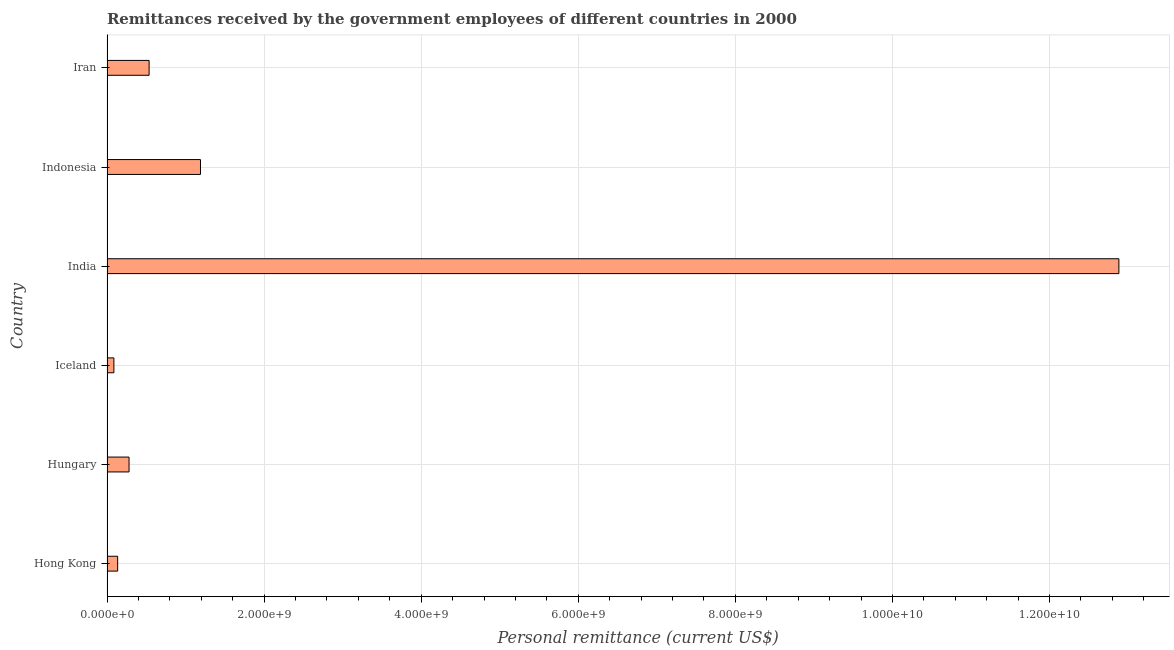Does the graph contain any zero values?
Offer a very short reply. No. What is the title of the graph?
Offer a very short reply. Remittances received by the government employees of different countries in 2000. What is the label or title of the X-axis?
Keep it short and to the point. Personal remittance (current US$). What is the label or title of the Y-axis?
Your response must be concise. Country. What is the personal remittances in Hungary?
Give a very brief answer. 2.81e+08. Across all countries, what is the maximum personal remittances?
Provide a succinct answer. 1.29e+1. Across all countries, what is the minimum personal remittances?
Your answer should be compact. 8.76e+07. In which country was the personal remittances maximum?
Give a very brief answer. India. What is the sum of the personal remittances?
Provide a succinct answer. 1.51e+1. What is the difference between the personal remittances in Hong Kong and Iran?
Your response must be concise. -4.00e+08. What is the average personal remittances per country?
Provide a succinct answer. 2.52e+09. What is the median personal remittances?
Offer a terse response. 4.08e+08. In how many countries, is the personal remittances greater than 8800000000 US$?
Your answer should be very brief. 1. What is the ratio of the personal remittances in Hong Kong to that in Iran?
Make the answer very short. 0.25. Is the personal remittances in Hungary less than that in Iran?
Give a very brief answer. Yes. What is the difference between the highest and the second highest personal remittances?
Your response must be concise. 1.17e+1. What is the difference between the highest and the lowest personal remittances?
Give a very brief answer. 1.28e+1. In how many countries, is the personal remittances greater than the average personal remittances taken over all countries?
Your response must be concise. 1. How many bars are there?
Your answer should be very brief. 6. Are all the bars in the graph horizontal?
Provide a short and direct response. Yes. How many countries are there in the graph?
Your answer should be very brief. 6. What is the difference between two consecutive major ticks on the X-axis?
Provide a short and direct response. 2.00e+09. What is the Personal remittance (current US$) of Hong Kong?
Your answer should be compact. 1.36e+08. What is the Personal remittance (current US$) in Hungary?
Offer a terse response. 2.81e+08. What is the Personal remittance (current US$) in Iceland?
Your answer should be compact. 8.76e+07. What is the Personal remittance (current US$) of India?
Your response must be concise. 1.29e+1. What is the Personal remittance (current US$) of Indonesia?
Ensure brevity in your answer.  1.19e+09. What is the Personal remittance (current US$) of Iran?
Provide a short and direct response. 5.36e+08. What is the difference between the Personal remittance (current US$) in Hong Kong and Hungary?
Your answer should be very brief. -1.45e+08. What is the difference between the Personal remittance (current US$) in Hong Kong and Iceland?
Provide a short and direct response. 4.79e+07. What is the difference between the Personal remittance (current US$) in Hong Kong and India?
Make the answer very short. -1.27e+1. What is the difference between the Personal remittance (current US$) in Hong Kong and Indonesia?
Offer a terse response. -1.05e+09. What is the difference between the Personal remittance (current US$) in Hong Kong and Iran?
Ensure brevity in your answer.  -4.00e+08. What is the difference between the Personal remittance (current US$) in Hungary and Iceland?
Offer a very short reply. 1.93e+08. What is the difference between the Personal remittance (current US$) in Hungary and India?
Offer a very short reply. -1.26e+1. What is the difference between the Personal remittance (current US$) in Hungary and Indonesia?
Ensure brevity in your answer.  -9.10e+08. What is the difference between the Personal remittance (current US$) in Hungary and Iran?
Your response must be concise. -2.55e+08. What is the difference between the Personal remittance (current US$) in Iceland and India?
Give a very brief answer. -1.28e+1. What is the difference between the Personal remittance (current US$) in Iceland and Indonesia?
Your answer should be compact. -1.10e+09. What is the difference between the Personal remittance (current US$) in Iceland and Iran?
Your response must be concise. -4.48e+08. What is the difference between the Personal remittance (current US$) in India and Indonesia?
Make the answer very short. 1.17e+1. What is the difference between the Personal remittance (current US$) in India and Iran?
Your answer should be very brief. 1.23e+1. What is the difference between the Personal remittance (current US$) in Indonesia and Iran?
Your response must be concise. 6.54e+08. What is the ratio of the Personal remittance (current US$) in Hong Kong to that in Hungary?
Give a very brief answer. 0.48. What is the ratio of the Personal remittance (current US$) in Hong Kong to that in Iceland?
Keep it short and to the point. 1.55. What is the ratio of the Personal remittance (current US$) in Hong Kong to that in India?
Provide a succinct answer. 0.01. What is the ratio of the Personal remittance (current US$) in Hong Kong to that in Indonesia?
Keep it short and to the point. 0.11. What is the ratio of the Personal remittance (current US$) in Hong Kong to that in Iran?
Provide a short and direct response. 0.25. What is the ratio of the Personal remittance (current US$) in Hungary to that in Iceland?
Make the answer very short. 3.2. What is the ratio of the Personal remittance (current US$) in Hungary to that in India?
Provide a short and direct response. 0.02. What is the ratio of the Personal remittance (current US$) in Hungary to that in Indonesia?
Provide a short and direct response. 0.24. What is the ratio of the Personal remittance (current US$) in Hungary to that in Iran?
Offer a terse response. 0.52. What is the ratio of the Personal remittance (current US$) in Iceland to that in India?
Your response must be concise. 0.01. What is the ratio of the Personal remittance (current US$) in Iceland to that in Indonesia?
Offer a terse response. 0.07. What is the ratio of the Personal remittance (current US$) in Iceland to that in Iran?
Provide a succinct answer. 0.16. What is the ratio of the Personal remittance (current US$) in India to that in Indonesia?
Offer a very short reply. 10.82. What is the ratio of the Personal remittance (current US$) in India to that in Iran?
Ensure brevity in your answer.  24.04. What is the ratio of the Personal remittance (current US$) in Indonesia to that in Iran?
Provide a short and direct response. 2.22. 